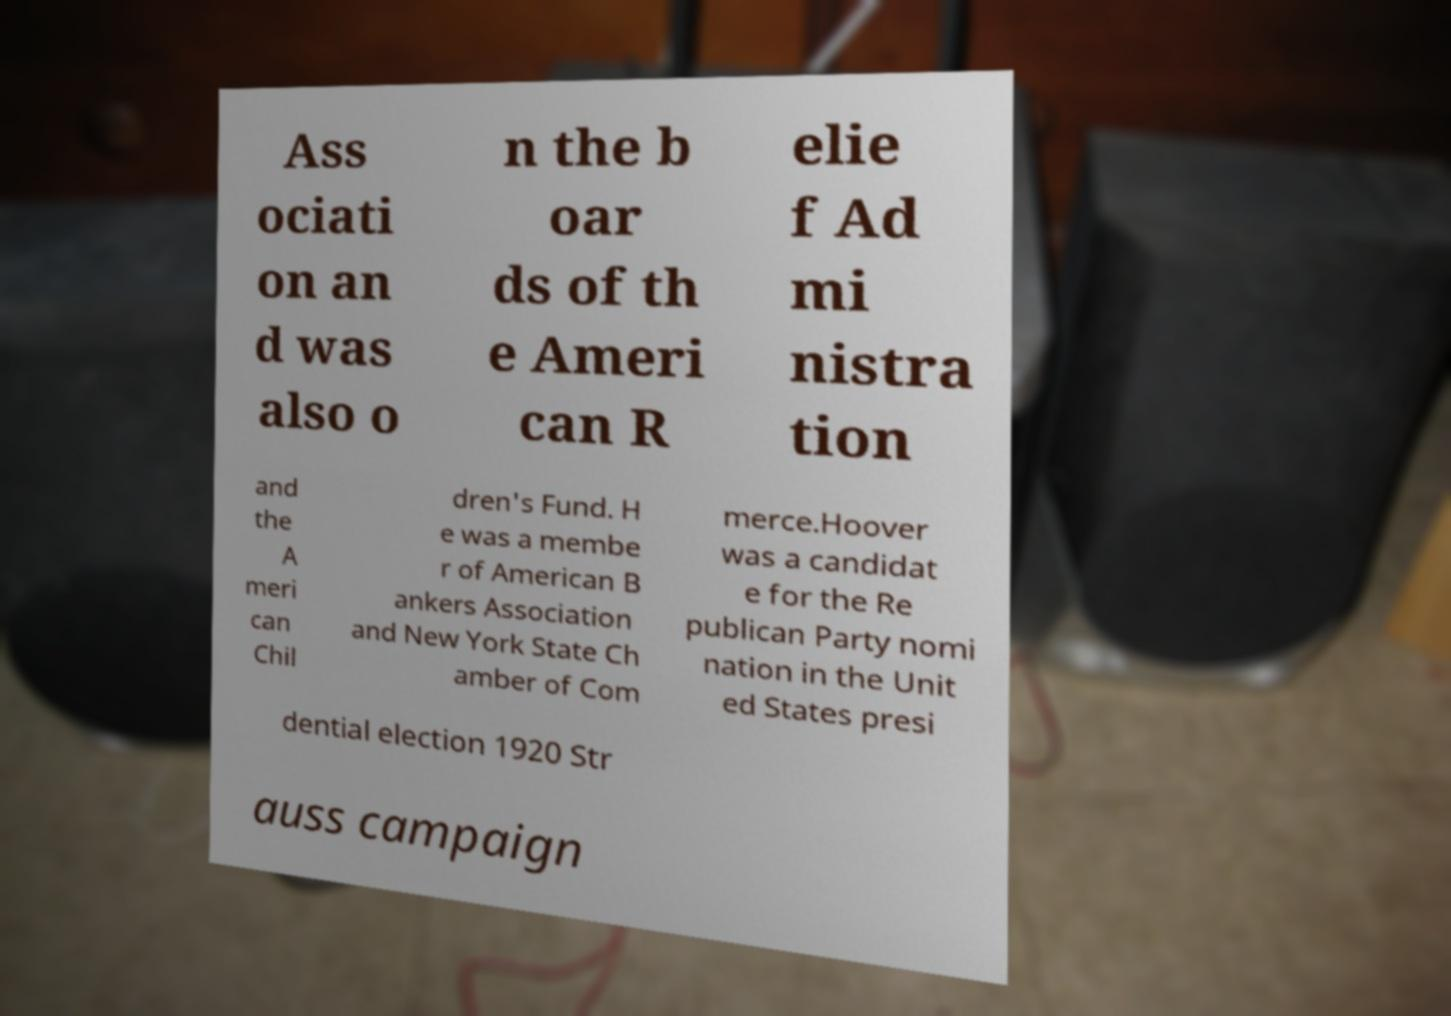Could you assist in decoding the text presented in this image and type it out clearly? Ass ociati on an d was also o n the b oar ds of th e Ameri can R elie f Ad mi nistra tion and the A meri can Chil dren's Fund. H e was a membe r of American B ankers Association and New York State Ch amber of Com merce.Hoover was a candidat e for the Re publican Party nomi nation in the Unit ed States presi dential election 1920 Str auss campaign 